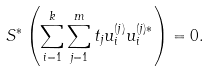Convert formula to latex. <formula><loc_0><loc_0><loc_500><loc_500>S ^ { * } \left ( \sum _ { i = 1 } ^ { k } \sum _ { j = 1 } ^ { m } t _ { j } u ^ { ( j ) } _ { i } u _ { i } ^ { ( j ) * } \right ) = 0 .</formula> 